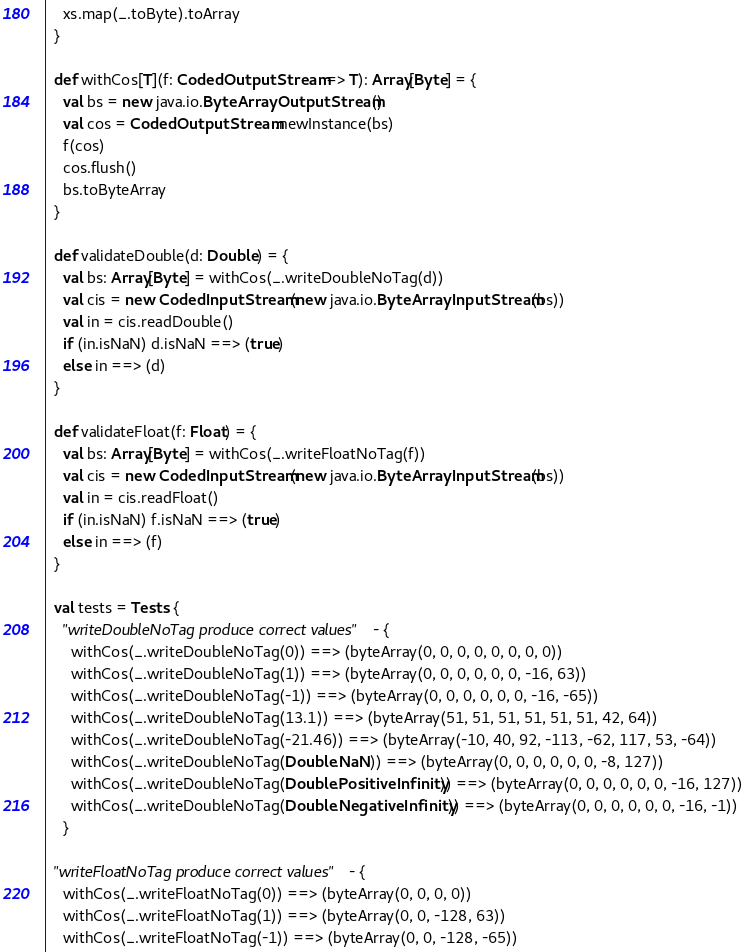<code> <loc_0><loc_0><loc_500><loc_500><_Scala_>    xs.map(_.toByte).toArray
  }

  def withCos[T](f: CodedOutputStream => T): Array[Byte] = {
    val bs = new java.io.ByteArrayOutputStream()
    val cos = CodedOutputStream.newInstance(bs)
    f(cos)
    cos.flush()
    bs.toByteArray
  }

  def validateDouble(d: Double) = {
    val bs: Array[Byte] = withCos(_.writeDoubleNoTag(d))
    val cis = new CodedInputStream(new java.io.ByteArrayInputStream(bs))
    val in = cis.readDouble()
    if (in.isNaN) d.isNaN ==> (true)
    else in ==> (d)
  }

  def validateFloat(f: Float) = {
    val bs: Array[Byte] = withCos(_.writeFloatNoTag(f))
    val cis = new CodedInputStream(new java.io.ByteArrayInputStream(bs))
    val in = cis.readFloat()
    if (in.isNaN) f.isNaN ==> (true)
    else in ==> (f)
  }

  val tests = Tests {
    "writeDoubleNoTag produce correct values" - {
      withCos(_.writeDoubleNoTag(0)) ==> (byteArray(0, 0, 0, 0, 0, 0, 0, 0))
      withCos(_.writeDoubleNoTag(1)) ==> (byteArray(0, 0, 0, 0, 0, 0, -16, 63))
      withCos(_.writeDoubleNoTag(-1)) ==> (byteArray(0, 0, 0, 0, 0, 0, -16, -65))
      withCos(_.writeDoubleNoTag(13.1)) ==> (byteArray(51, 51, 51, 51, 51, 51, 42, 64))
      withCos(_.writeDoubleNoTag(-21.46)) ==> (byteArray(-10, 40, 92, -113, -62, 117, 53, -64))
      withCos(_.writeDoubleNoTag(Double.NaN)) ==> (byteArray(0, 0, 0, 0, 0, 0, -8, 127))
      withCos(_.writeDoubleNoTag(Double.PositiveInfinity)) ==> (byteArray(0, 0, 0, 0, 0, 0, -16, 127))
      withCos(_.writeDoubleNoTag(Double.NegativeInfinity)) ==> (byteArray(0, 0, 0, 0, 0, 0, -16, -1))
    }

  "writeFloatNoTag produce correct values" - {
    withCos(_.writeFloatNoTag(0)) ==> (byteArray(0, 0, 0, 0))
    withCos(_.writeFloatNoTag(1)) ==> (byteArray(0, 0, -128, 63))
    withCos(_.writeFloatNoTag(-1)) ==> (byteArray(0, 0, -128, -65))</code> 